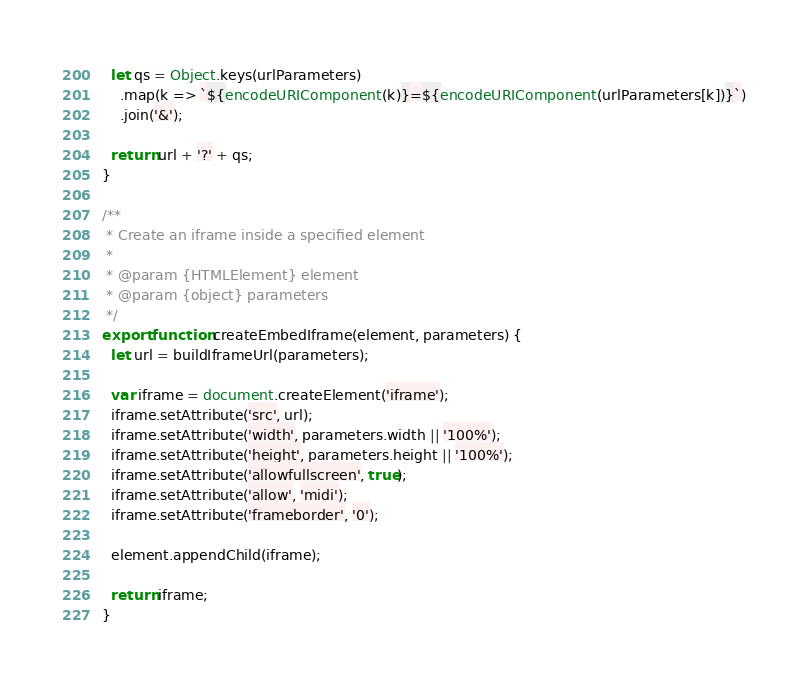Convert code to text. <code><loc_0><loc_0><loc_500><loc_500><_JavaScript_>
  let qs = Object.keys(urlParameters)
    .map(k => `${encodeURIComponent(k)}=${encodeURIComponent(urlParameters[k])}`)
    .join('&');

  return url + '?' + qs;
}

/**
 * Create an iframe inside a specified element
 *
 * @param {HTMLElement} element
 * @param {object} parameters
 */
export function createEmbedIframe(element, parameters) {
  let url = buildIframeUrl(parameters);

  var iframe = document.createElement('iframe');
  iframe.setAttribute('src', url);
  iframe.setAttribute('width', parameters.width || '100%');
  iframe.setAttribute('height', parameters.height || '100%');
  iframe.setAttribute('allowfullscreen', true);
  iframe.setAttribute('allow', 'midi');
  iframe.setAttribute('frameborder', '0');

  element.appendChild(iframe);

  return iframe;
}
</code> 